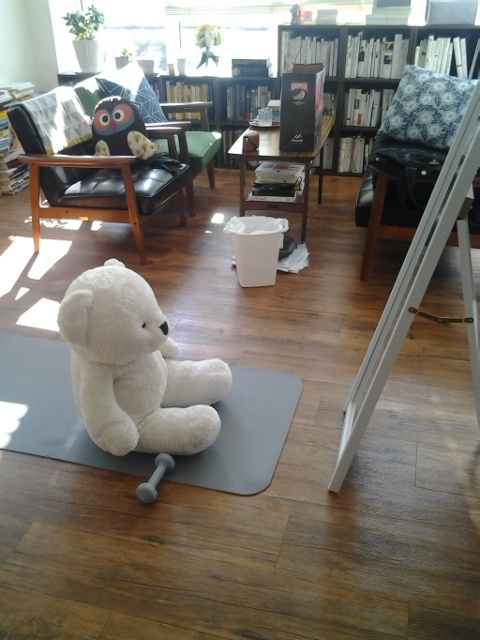Describe the objects in this image and their specific colors. I can see teddy bear in ivory, darkgray, and gray tones, book in ivory, gray, darkgray, black, and lightgray tones, chair in ivory, black, maroon, darkgray, and gray tones, chair in ivory, white, and gray tones, and chair in ivory, black, gray, maroon, and purple tones in this image. 